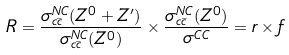<formula> <loc_0><loc_0><loc_500><loc_500>R = \frac { \sigma _ { c \bar { c } } ^ { N C } ( Z ^ { 0 } + Z ^ { \prime } ) } { \sigma _ { c \bar { c } } ^ { N C } ( Z ^ { 0 } ) } \times \frac { \sigma _ { c \bar { c } } ^ { N C } ( Z ^ { 0 } ) } { \sigma ^ { C C } } = r \times f</formula> 